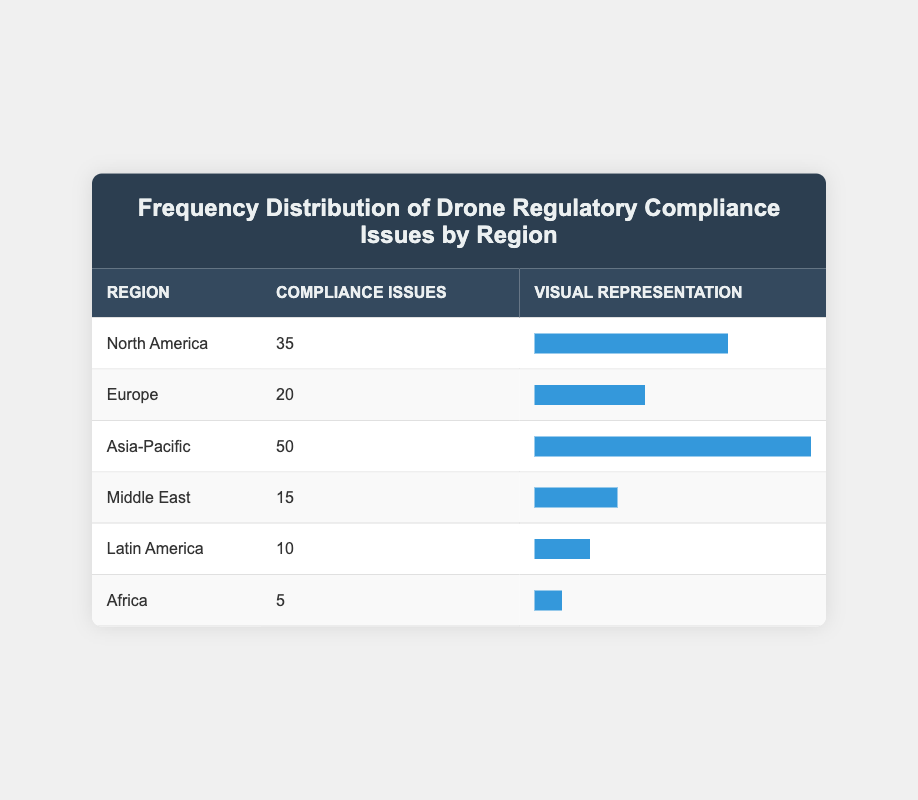What region has the highest number of compliance issues? By examining the table, we can see that the region labeled "Asia-Pacific" has a total of 50 compliance issues, which is greater than any other region listed.
Answer: Asia-Pacific Which region has the lowest incidence of compliance issues? Looking at the table, "Africa" is the region with only 5 compliance issues, which is the smallest value in the table.
Answer: Africa What is the total number of compliance issues across all regions? To find the total, we add the compliance issues from each region: 35 (North America) + 20 (Europe) + 50 (Asia-Pacific) + 15 (Middle East) + 10 (Latin America) + 5 (Africa) = 135.
Answer: 135 Is it true that Europe has more compliance issues than Latin America? From the table, Europe has 20 compliance issues and Latin America has 10. Since 20 is greater than 10, this statement is true.
Answer: Yes What is the average number of compliance issues among all regions listed? To calculate the average, we sum up all compliance issues (135) and divide by the number of regions (6). So, 135 / 6 = 22.5.
Answer: 22.5 Which two regions together have a total of 55 compliance issues? Identifying the values, North America has 35 compliance issues and Middle East has 15. If we add them (35 + 15), we find that the sum is 50, not 55. Instead, Asia-Pacific (50) and Africa (5) total 55; however, no other regions combine to make that total either. Hence, no two regions total 55 compliance issues.
Answer: No How many more compliance issues does North America have compared to Africa? North America has 35 compliance issues and Africa has 5. By subtracting the two values (35 - 5), we find that North America has 30 more compliance issues than Africa.
Answer: 30 Which region has a compliance issue percentage closest to the median of all regions? The compliance issues sorted in increasing order are: 5 (Africa), 10 (Latin America), 15 (Middle East), 20 (Europe), 35 (North America), 50 (Asia-Pacific). The median is between 20 and 35, which is 27.5. Europe is the only region with a value closest to it (20), being lower.
Answer: Europe What percentage of total compliance issues does Asia-Pacific represent? Asia-Pacific has 50 compliance issues out of a total of 135. To find the percentage, (50 / 135) * 100 = 37.04%. Thus, Asia-Pacific comprises approximately 37% of total compliance issues.
Answer: 37% 